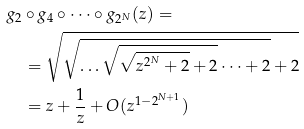Convert formula to latex. <formula><loc_0><loc_0><loc_500><loc_500>& g _ { 2 } \circ g _ { 4 } \circ \dots \circ g _ { 2 ^ { N } } ( z ) = \\ & \quad = \sqrt { \sqrt { \dots \sqrt { \sqrt { z ^ { 2 ^ { N } } + 2 } + 2 } \dots + 2 } + 2 } \\ & \quad = z + \frac { 1 } { z } + O ( z ^ { 1 - 2 ^ { N + 1 } } )</formula> 